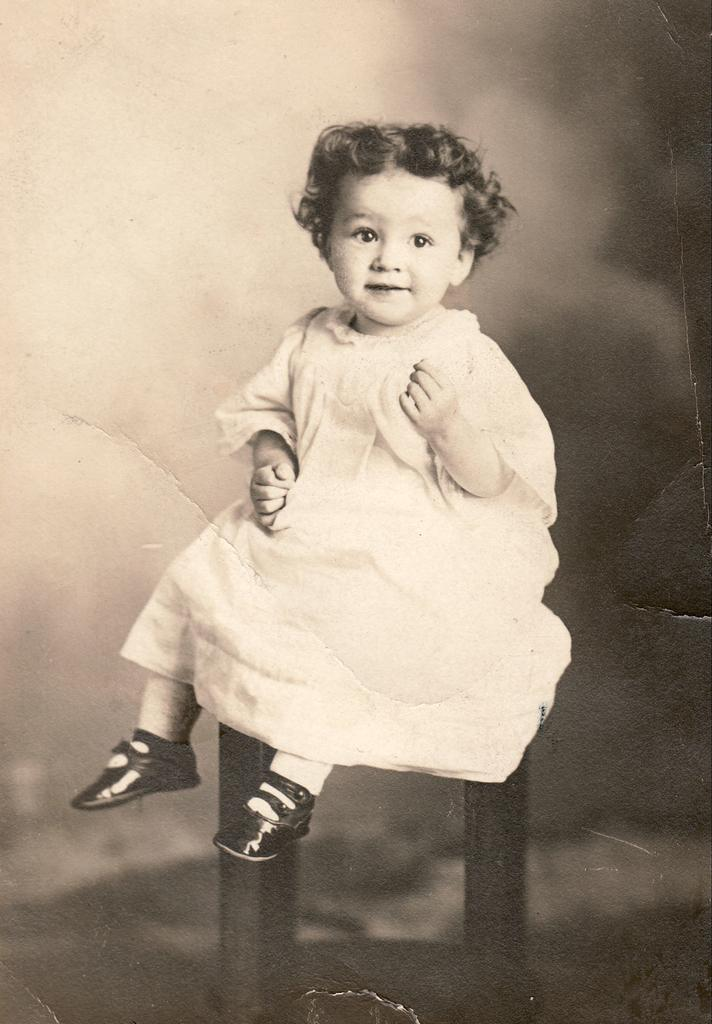What is the color scheme of the image? The image is black and white. What can be seen in the image? There is a baby in the image. What is the baby sitting on? The baby is sitting on a stool. What year is the baby celebrating a feast in the image? There is no indication of a feast or a specific year in the image; it simply shows a baby sitting on a stool. 